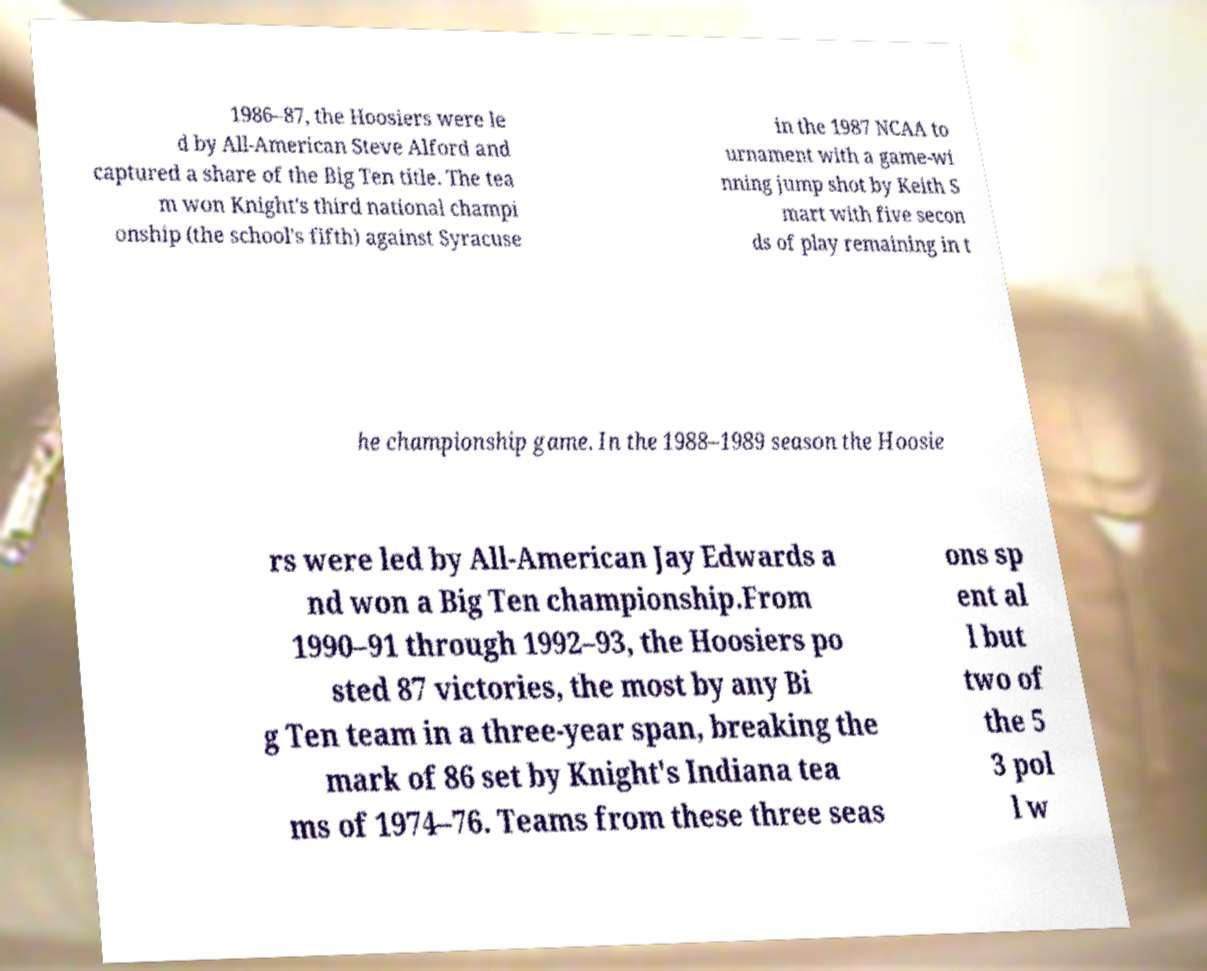For documentation purposes, I need the text within this image transcribed. Could you provide that? 1986–87, the Hoosiers were le d by All-American Steve Alford and captured a share of the Big Ten title. The tea m won Knight's third national champi onship (the school's fifth) against Syracuse in the 1987 NCAA to urnament with a game-wi nning jump shot by Keith S mart with five secon ds of play remaining in t he championship game. In the 1988–1989 season the Hoosie rs were led by All-American Jay Edwards a nd won a Big Ten championship.From 1990–91 through 1992–93, the Hoosiers po sted 87 victories, the most by any Bi g Ten team in a three-year span, breaking the mark of 86 set by Knight's Indiana tea ms of 1974–76. Teams from these three seas ons sp ent al l but two of the 5 3 pol l w 